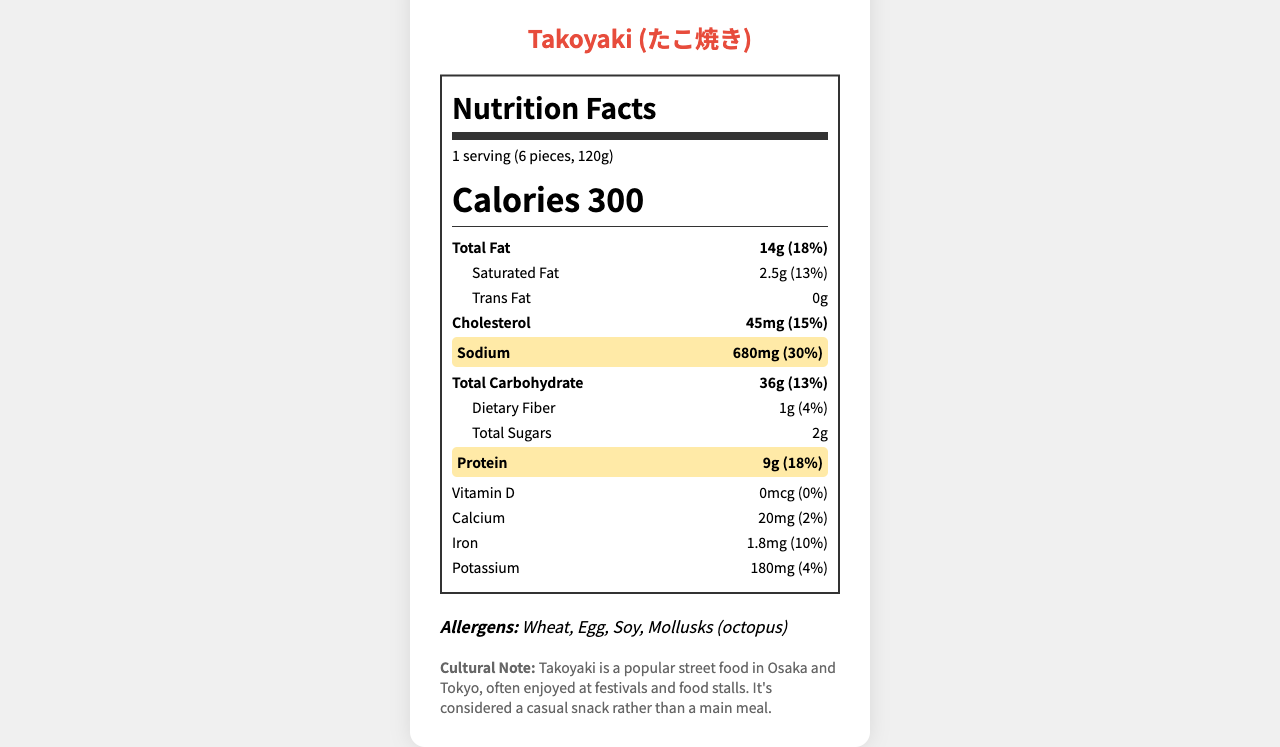what is the sodium content in Takoyaki? The sodium content is explicitly stated in the document under the nutrient highlighted section as 680 mg.
Answer: 680 mg what percentage of daily value does the protein content represent? The protein content is given as 9g, which corresponds to 18% of the daily value as noted in the highlight section for protein.
Answer: 18% what is the serving size for Takoyaki? The serving size is clearly mentioned at the beginning of the document as "1 serving (6 pieces, 120g)".
Answer: 1 serving (6 pieces, 120g) how many calories are in a serving of Takoyaki? The calories in a serving of Takoyaki are prominently listed as 300 in the document.
Answer: 300 calories what are the main allergens in Takoyaki? The allergens are explicitly listed towards the end of the document as Wheat, Egg, Soy, Mollusks (octopus).
Answer: Wheat, Egg, Soy, Mollusks (octopus) how much saturated fat is in Takoyaki? The saturated fat content is listed in the document as 2.5 g, which is 13% of the daily value.
Answer: 2.5 g what is the percentage daily value for sodium in Takoyaki? The document specifies that the sodium content represents 30% of the daily value, highlighted in the nutrient section.
Answer: 30% which of the following is NOT an ingredient in Takoyaki? A. Wheat flour B. Octopus C. Rice flour D. Soy sauce The ingredients section lists Wheat flour, Octopus, and Soy sauce, but not Rice flour.
Answer: C how many grams of total sugars are in a serving of Takoyaki? The document states that there are 2 g of total sugars in a serving.
Answer: 2 g is there any trans fat in Takoyaki? (Yes/No) The document lists trans fat as 0 g, indicating there is no trans fat in Takoyaki.
Answer: No what is the main cultural context of Takoyaki? The cultural note section provides this detailed explanation about the context in which Takoyaki is commonly enjoyed.
Answer: Takoyaki is a popular street food in Osaka and Tokyo, often enjoyed at festivals and food stalls. It's considered a casual snack rather than a main meal. does Takoyaki contain more potassium or iron? The document lists the potassium content as 180 mg and the iron content as 1.8 mg, indicating a significantly higher amount of potassium by weight.
Answer: Potassium (180 mg) what is the vitamin D content in Takoyaki? The document states that Takoyaki contains 0 mcg of vitamin D.
Answer: 0 mcg how many grams of dietary fiber are in Takoyaki? A. 1 g B. 2 g C. 3 g The dietary fiber content is listed in the document as 1 g, making option A the correct answer.
Answer: A what is the main cooking method used for Takoyaki? The cooking method is specified in the document as "Grilled in a special molded pan".
Answer: Grilled in a special molded pan describe the Nutrition Facts Label for Takoyaki briefly. The summary captures the key elements of the nutrition facts, allergens, and cultural note as provided in the document.
Answer: The Nutrition Facts Label for Takoyaki provides detailed nutrient information per serving size (6 pieces, 120g), highlighting macronutrients like calories (300), total fat (14g), saturated fat (2.5g), cholesterol (45mg), sodium (680mg), and protein (9g). Allergens include wheat, egg, soy, and mollusks (octopus). A cultural note describes Takoyaki as a popular casual snack in Tokyo and Osaka. what is the cholesterol content in Takoyaki? The cholesterol content is listed in the document as 45 mg, equating to 15% of the daily value.
Answer: 45 mg what are common toppings for Takoyaki? A. Takoyaki sauce B. Japanese mayonnaise C. Dried bonito flakes D. All of the above The document lists Takoyaki sauce, Japanese mayonnaise, and dried bonito flakes (katsuobushi) as common toppings, making "All of the above" the correct answer.
Answer: D how much calcium does Takoyaki contain? The document specifies that Takoyaki contains 20 mg of calcium, making up 2% of the daily value.
Answer: 20 mg what type of oil is used in Takoyaki? The ingredients list includes vegetable oil as one of the components used in Takoyaki.
Answer: Vegetable oil who invented Takoyaki? The document does not provide information about the inventor of Takoyaki.
Answer: Not enough information 